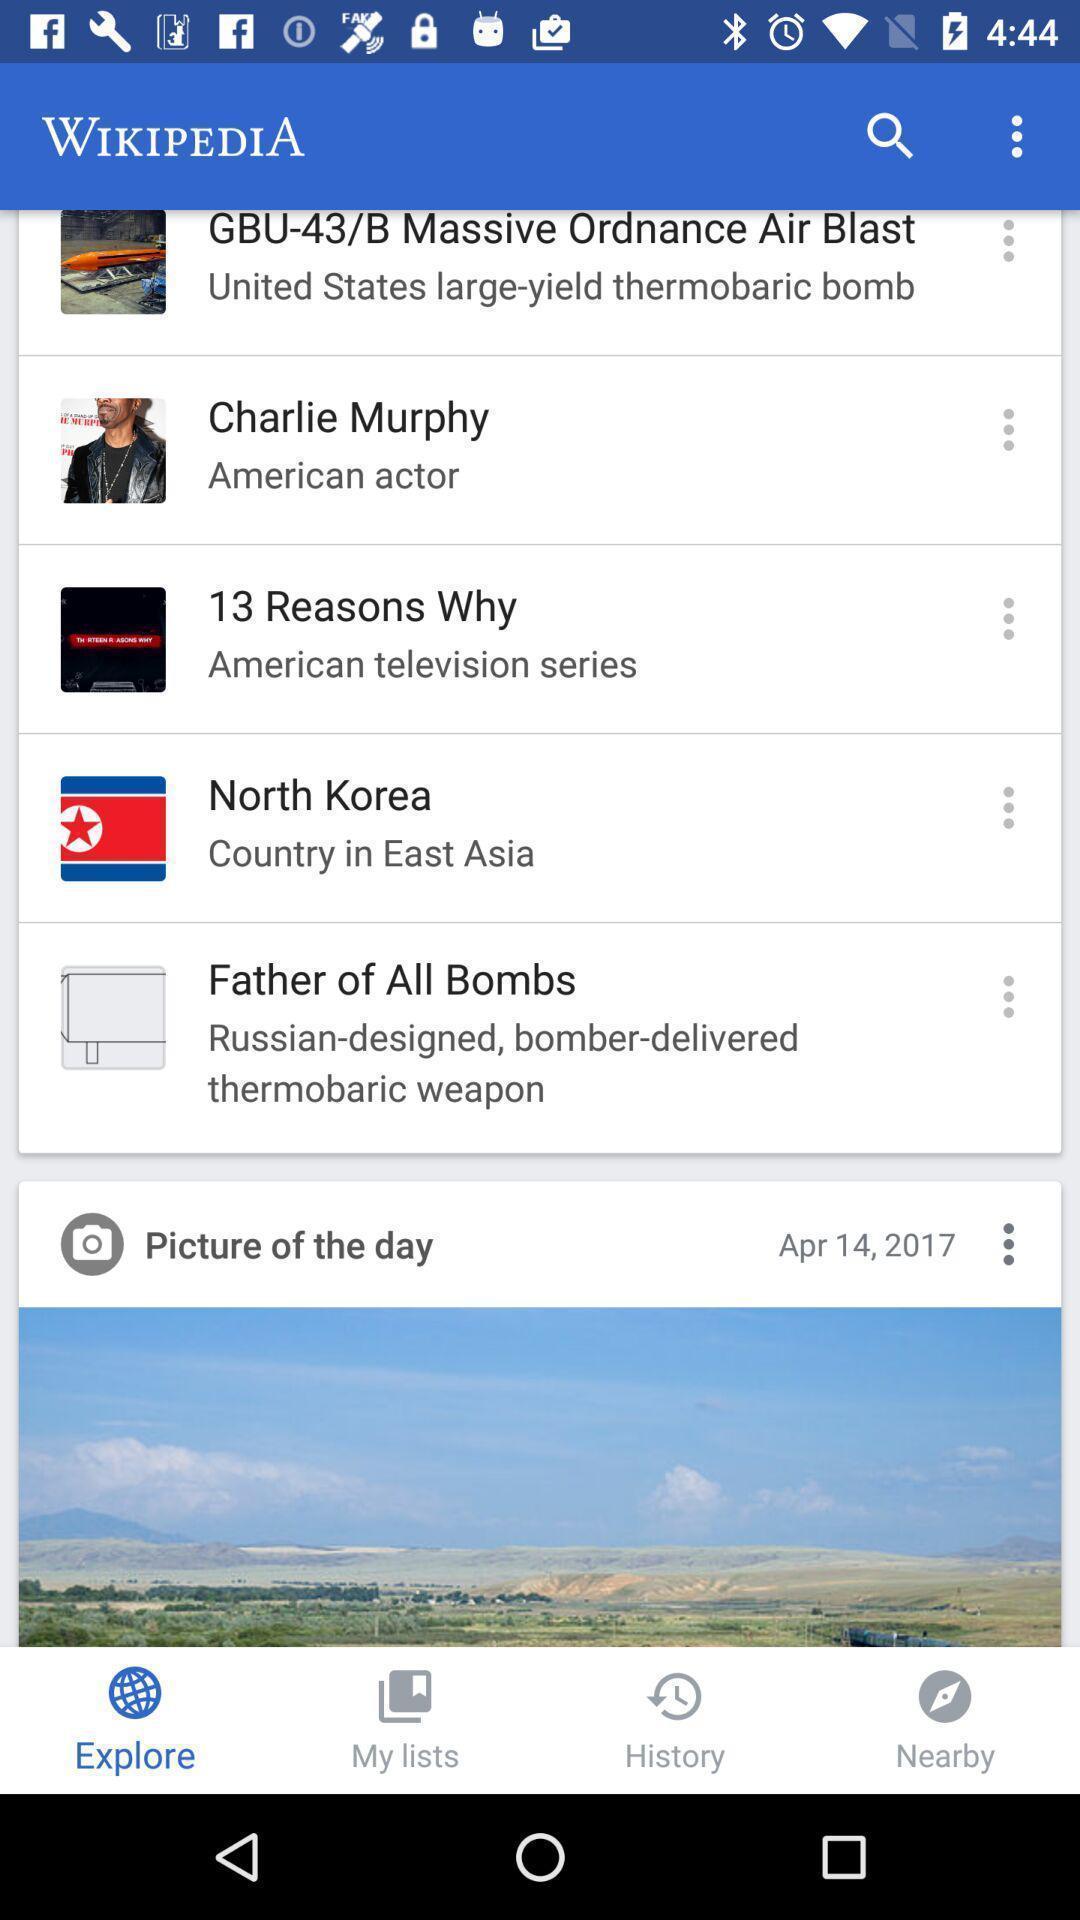Describe the key features of this screenshot. Page for exploring different information. 